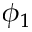Convert formula to latex. <formula><loc_0><loc_0><loc_500><loc_500>\phi _ { 1 }</formula> 